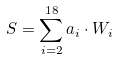Convert formula to latex. <formula><loc_0><loc_0><loc_500><loc_500>S = \sum _ { i = 2 } ^ { 1 8 } a _ { i } \cdot W _ { i }</formula> 